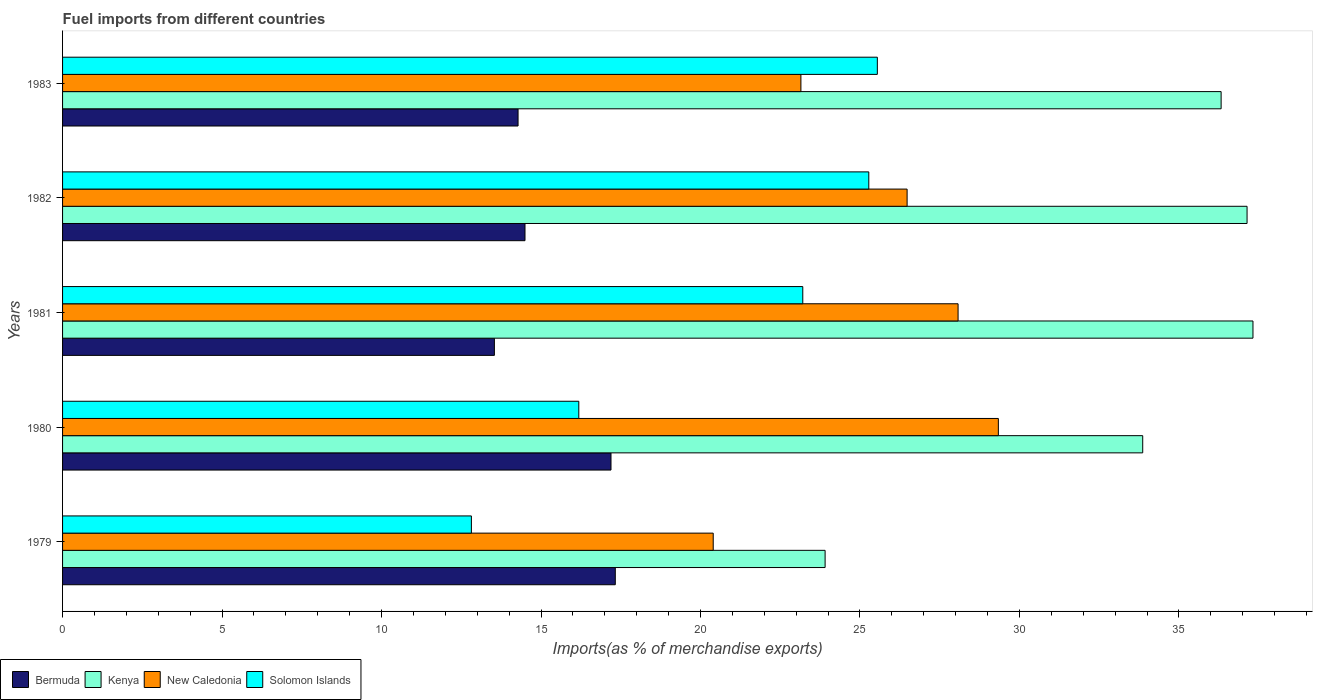Are the number of bars per tick equal to the number of legend labels?
Ensure brevity in your answer.  Yes. How many bars are there on the 2nd tick from the bottom?
Make the answer very short. 4. What is the label of the 3rd group of bars from the top?
Your answer should be very brief. 1981. What is the percentage of imports to different countries in Kenya in 1983?
Your answer should be compact. 36.32. Across all years, what is the maximum percentage of imports to different countries in Bermuda?
Ensure brevity in your answer.  17.33. Across all years, what is the minimum percentage of imports to different countries in Kenya?
Offer a very short reply. 23.91. In which year was the percentage of imports to different countries in Bermuda maximum?
Offer a very short reply. 1979. In which year was the percentage of imports to different countries in New Caledonia minimum?
Offer a very short reply. 1979. What is the total percentage of imports to different countries in New Caledonia in the graph?
Your answer should be very brief. 127.44. What is the difference between the percentage of imports to different countries in New Caledonia in 1980 and that in 1981?
Offer a terse response. 1.26. What is the difference between the percentage of imports to different countries in Bermuda in 1983 and the percentage of imports to different countries in Solomon Islands in 1982?
Your response must be concise. -11. What is the average percentage of imports to different countries in Kenya per year?
Offer a very short reply. 33.71. In the year 1980, what is the difference between the percentage of imports to different countries in New Caledonia and percentage of imports to different countries in Solomon Islands?
Keep it short and to the point. 13.15. In how many years, is the percentage of imports to different countries in Kenya greater than 22 %?
Offer a terse response. 5. What is the ratio of the percentage of imports to different countries in Bermuda in 1979 to that in 1983?
Your answer should be compact. 1.21. What is the difference between the highest and the second highest percentage of imports to different countries in Kenya?
Your answer should be very brief. 0.19. What is the difference between the highest and the lowest percentage of imports to different countries in New Caledonia?
Your answer should be compact. 8.94. In how many years, is the percentage of imports to different countries in Kenya greater than the average percentage of imports to different countries in Kenya taken over all years?
Your answer should be compact. 4. Is it the case that in every year, the sum of the percentage of imports to different countries in Bermuda and percentage of imports to different countries in Solomon Islands is greater than the sum of percentage of imports to different countries in Kenya and percentage of imports to different countries in New Caledonia?
Offer a very short reply. No. What does the 1st bar from the top in 1981 represents?
Your answer should be compact. Solomon Islands. What does the 2nd bar from the bottom in 1983 represents?
Keep it short and to the point. Kenya. Are all the bars in the graph horizontal?
Ensure brevity in your answer.  Yes. What is the difference between two consecutive major ticks on the X-axis?
Keep it short and to the point. 5. Are the values on the major ticks of X-axis written in scientific E-notation?
Your answer should be compact. No. What is the title of the graph?
Your response must be concise. Fuel imports from different countries. What is the label or title of the X-axis?
Provide a succinct answer. Imports(as % of merchandise exports). What is the label or title of the Y-axis?
Ensure brevity in your answer.  Years. What is the Imports(as % of merchandise exports) in Bermuda in 1979?
Your response must be concise. 17.33. What is the Imports(as % of merchandise exports) in Kenya in 1979?
Your answer should be compact. 23.91. What is the Imports(as % of merchandise exports) of New Caledonia in 1979?
Ensure brevity in your answer.  20.4. What is the Imports(as % of merchandise exports) of Solomon Islands in 1979?
Your answer should be compact. 12.82. What is the Imports(as % of merchandise exports) in Bermuda in 1980?
Give a very brief answer. 17.19. What is the Imports(as % of merchandise exports) of Kenya in 1980?
Keep it short and to the point. 33.86. What is the Imports(as % of merchandise exports) of New Caledonia in 1980?
Your response must be concise. 29.34. What is the Imports(as % of merchandise exports) in Solomon Islands in 1980?
Ensure brevity in your answer.  16.18. What is the Imports(as % of merchandise exports) in Bermuda in 1981?
Provide a short and direct response. 13.54. What is the Imports(as % of merchandise exports) in Kenya in 1981?
Give a very brief answer. 37.32. What is the Imports(as % of merchandise exports) of New Caledonia in 1981?
Provide a succinct answer. 28.08. What is the Imports(as % of merchandise exports) in Solomon Islands in 1981?
Your answer should be compact. 23.21. What is the Imports(as % of merchandise exports) of Bermuda in 1982?
Give a very brief answer. 14.5. What is the Imports(as % of merchandise exports) in Kenya in 1982?
Provide a succinct answer. 37.14. What is the Imports(as % of merchandise exports) in New Caledonia in 1982?
Provide a succinct answer. 26.48. What is the Imports(as % of merchandise exports) in Solomon Islands in 1982?
Offer a very short reply. 25.28. What is the Imports(as % of merchandise exports) in Bermuda in 1983?
Offer a terse response. 14.28. What is the Imports(as % of merchandise exports) of Kenya in 1983?
Your answer should be very brief. 36.32. What is the Imports(as % of merchandise exports) in New Caledonia in 1983?
Offer a very short reply. 23.15. What is the Imports(as % of merchandise exports) in Solomon Islands in 1983?
Your answer should be compact. 25.54. Across all years, what is the maximum Imports(as % of merchandise exports) in Bermuda?
Offer a very short reply. 17.33. Across all years, what is the maximum Imports(as % of merchandise exports) in Kenya?
Your response must be concise. 37.32. Across all years, what is the maximum Imports(as % of merchandise exports) in New Caledonia?
Offer a very short reply. 29.34. Across all years, what is the maximum Imports(as % of merchandise exports) of Solomon Islands?
Provide a succinct answer. 25.54. Across all years, what is the minimum Imports(as % of merchandise exports) of Bermuda?
Provide a short and direct response. 13.54. Across all years, what is the minimum Imports(as % of merchandise exports) of Kenya?
Offer a very short reply. 23.91. Across all years, what is the minimum Imports(as % of merchandise exports) of New Caledonia?
Your response must be concise. 20.4. Across all years, what is the minimum Imports(as % of merchandise exports) in Solomon Islands?
Provide a short and direct response. 12.82. What is the total Imports(as % of merchandise exports) of Bermuda in the graph?
Ensure brevity in your answer.  76.84. What is the total Imports(as % of merchandise exports) in Kenya in the graph?
Your response must be concise. 168.55. What is the total Imports(as % of merchandise exports) in New Caledonia in the graph?
Ensure brevity in your answer.  127.44. What is the total Imports(as % of merchandise exports) of Solomon Islands in the graph?
Offer a terse response. 103.03. What is the difference between the Imports(as % of merchandise exports) in Bermuda in 1979 and that in 1980?
Offer a terse response. 0.14. What is the difference between the Imports(as % of merchandise exports) of Kenya in 1979 and that in 1980?
Provide a short and direct response. -9.96. What is the difference between the Imports(as % of merchandise exports) in New Caledonia in 1979 and that in 1980?
Keep it short and to the point. -8.94. What is the difference between the Imports(as % of merchandise exports) in Solomon Islands in 1979 and that in 1980?
Provide a succinct answer. -3.37. What is the difference between the Imports(as % of merchandise exports) in Bermuda in 1979 and that in 1981?
Your answer should be very brief. 3.79. What is the difference between the Imports(as % of merchandise exports) in Kenya in 1979 and that in 1981?
Provide a short and direct response. -13.41. What is the difference between the Imports(as % of merchandise exports) in New Caledonia in 1979 and that in 1981?
Your response must be concise. -7.68. What is the difference between the Imports(as % of merchandise exports) of Solomon Islands in 1979 and that in 1981?
Offer a very short reply. -10.39. What is the difference between the Imports(as % of merchandise exports) of Bermuda in 1979 and that in 1982?
Your response must be concise. 2.83. What is the difference between the Imports(as % of merchandise exports) of Kenya in 1979 and that in 1982?
Your answer should be compact. -13.23. What is the difference between the Imports(as % of merchandise exports) in New Caledonia in 1979 and that in 1982?
Provide a succinct answer. -6.08. What is the difference between the Imports(as % of merchandise exports) in Solomon Islands in 1979 and that in 1982?
Your answer should be very brief. -12.46. What is the difference between the Imports(as % of merchandise exports) of Bermuda in 1979 and that in 1983?
Offer a very short reply. 3.05. What is the difference between the Imports(as % of merchandise exports) of Kenya in 1979 and that in 1983?
Your answer should be very brief. -12.42. What is the difference between the Imports(as % of merchandise exports) in New Caledonia in 1979 and that in 1983?
Your answer should be very brief. -2.75. What is the difference between the Imports(as % of merchandise exports) of Solomon Islands in 1979 and that in 1983?
Keep it short and to the point. -12.73. What is the difference between the Imports(as % of merchandise exports) in Bermuda in 1980 and that in 1981?
Your answer should be compact. 3.66. What is the difference between the Imports(as % of merchandise exports) in Kenya in 1980 and that in 1981?
Offer a terse response. -3.46. What is the difference between the Imports(as % of merchandise exports) in New Caledonia in 1980 and that in 1981?
Your answer should be very brief. 1.26. What is the difference between the Imports(as % of merchandise exports) of Solomon Islands in 1980 and that in 1981?
Ensure brevity in your answer.  -7.02. What is the difference between the Imports(as % of merchandise exports) of Bermuda in 1980 and that in 1982?
Offer a terse response. 2.7. What is the difference between the Imports(as % of merchandise exports) of Kenya in 1980 and that in 1982?
Provide a succinct answer. -3.27. What is the difference between the Imports(as % of merchandise exports) of New Caledonia in 1980 and that in 1982?
Your response must be concise. 2.86. What is the difference between the Imports(as % of merchandise exports) of Solomon Islands in 1980 and that in 1982?
Offer a terse response. -9.09. What is the difference between the Imports(as % of merchandise exports) in Bermuda in 1980 and that in 1983?
Give a very brief answer. 2.91. What is the difference between the Imports(as % of merchandise exports) of Kenya in 1980 and that in 1983?
Keep it short and to the point. -2.46. What is the difference between the Imports(as % of merchandise exports) of New Caledonia in 1980 and that in 1983?
Your answer should be compact. 6.19. What is the difference between the Imports(as % of merchandise exports) in Solomon Islands in 1980 and that in 1983?
Give a very brief answer. -9.36. What is the difference between the Imports(as % of merchandise exports) in Bermuda in 1981 and that in 1982?
Your answer should be very brief. -0.96. What is the difference between the Imports(as % of merchandise exports) of Kenya in 1981 and that in 1982?
Provide a succinct answer. 0.19. What is the difference between the Imports(as % of merchandise exports) of New Caledonia in 1981 and that in 1982?
Your answer should be very brief. 1.6. What is the difference between the Imports(as % of merchandise exports) in Solomon Islands in 1981 and that in 1982?
Provide a short and direct response. -2.07. What is the difference between the Imports(as % of merchandise exports) of Bermuda in 1981 and that in 1983?
Ensure brevity in your answer.  -0.74. What is the difference between the Imports(as % of merchandise exports) of Kenya in 1981 and that in 1983?
Provide a succinct answer. 1. What is the difference between the Imports(as % of merchandise exports) in New Caledonia in 1981 and that in 1983?
Provide a succinct answer. 4.93. What is the difference between the Imports(as % of merchandise exports) in Solomon Islands in 1981 and that in 1983?
Your response must be concise. -2.34. What is the difference between the Imports(as % of merchandise exports) of Bermuda in 1982 and that in 1983?
Make the answer very short. 0.22. What is the difference between the Imports(as % of merchandise exports) in Kenya in 1982 and that in 1983?
Offer a very short reply. 0.81. What is the difference between the Imports(as % of merchandise exports) in New Caledonia in 1982 and that in 1983?
Provide a short and direct response. 3.33. What is the difference between the Imports(as % of merchandise exports) in Solomon Islands in 1982 and that in 1983?
Your response must be concise. -0.27. What is the difference between the Imports(as % of merchandise exports) of Bermuda in 1979 and the Imports(as % of merchandise exports) of Kenya in 1980?
Offer a very short reply. -16.54. What is the difference between the Imports(as % of merchandise exports) of Bermuda in 1979 and the Imports(as % of merchandise exports) of New Caledonia in 1980?
Keep it short and to the point. -12.01. What is the difference between the Imports(as % of merchandise exports) of Bermuda in 1979 and the Imports(as % of merchandise exports) of Solomon Islands in 1980?
Keep it short and to the point. 1.14. What is the difference between the Imports(as % of merchandise exports) of Kenya in 1979 and the Imports(as % of merchandise exports) of New Caledonia in 1980?
Offer a very short reply. -5.43. What is the difference between the Imports(as % of merchandise exports) in Kenya in 1979 and the Imports(as % of merchandise exports) in Solomon Islands in 1980?
Provide a short and direct response. 7.72. What is the difference between the Imports(as % of merchandise exports) in New Caledonia in 1979 and the Imports(as % of merchandise exports) in Solomon Islands in 1980?
Ensure brevity in your answer.  4.21. What is the difference between the Imports(as % of merchandise exports) of Bermuda in 1979 and the Imports(as % of merchandise exports) of Kenya in 1981?
Offer a very short reply. -19.99. What is the difference between the Imports(as % of merchandise exports) in Bermuda in 1979 and the Imports(as % of merchandise exports) in New Caledonia in 1981?
Provide a short and direct response. -10.75. What is the difference between the Imports(as % of merchandise exports) of Bermuda in 1979 and the Imports(as % of merchandise exports) of Solomon Islands in 1981?
Provide a short and direct response. -5.88. What is the difference between the Imports(as % of merchandise exports) of Kenya in 1979 and the Imports(as % of merchandise exports) of New Caledonia in 1981?
Offer a terse response. -4.17. What is the difference between the Imports(as % of merchandise exports) in Kenya in 1979 and the Imports(as % of merchandise exports) in Solomon Islands in 1981?
Ensure brevity in your answer.  0.7. What is the difference between the Imports(as % of merchandise exports) in New Caledonia in 1979 and the Imports(as % of merchandise exports) in Solomon Islands in 1981?
Make the answer very short. -2.81. What is the difference between the Imports(as % of merchandise exports) of Bermuda in 1979 and the Imports(as % of merchandise exports) of Kenya in 1982?
Offer a very short reply. -19.81. What is the difference between the Imports(as % of merchandise exports) in Bermuda in 1979 and the Imports(as % of merchandise exports) in New Caledonia in 1982?
Keep it short and to the point. -9.15. What is the difference between the Imports(as % of merchandise exports) of Bermuda in 1979 and the Imports(as % of merchandise exports) of Solomon Islands in 1982?
Offer a very short reply. -7.95. What is the difference between the Imports(as % of merchandise exports) of Kenya in 1979 and the Imports(as % of merchandise exports) of New Caledonia in 1982?
Provide a short and direct response. -2.57. What is the difference between the Imports(as % of merchandise exports) of Kenya in 1979 and the Imports(as % of merchandise exports) of Solomon Islands in 1982?
Offer a terse response. -1.37. What is the difference between the Imports(as % of merchandise exports) of New Caledonia in 1979 and the Imports(as % of merchandise exports) of Solomon Islands in 1982?
Keep it short and to the point. -4.88. What is the difference between the Imports(as % of merchandise exports) in Bermuda in 1979 and the Imports(as % of merchandise exports) in Kenya in 1983?
Give a very brief answer. -18.99. What is the difference between the Imports(as % of merchandise exports) of Bermuda in 1979 and the Imports(as % of merchandise exports) of New Caledonia in 1983?
Your answer should be very brief. -5.82. What is the difference between the Imports(as % of merchandise exports) in Bermuda in 1979 and the Imports(as % of merchandise exports) in Solomon Islands in 1983?
Provide a short and direct response. -8.22. What is the difference between the Imports(as % of merchandise exports) in Kenya in 1979 and the Imports(as % of merchandise exports) in New Caledonia in 1983?
Give a very brief answer. 0.76. What is the difference between the Imports(as % of merchandise exports) of Kenya in 1979 and the Imports(as % of merchandise exports) of Solomon Islands in 1983?
Give a very brief answer. -1.64. What is the difference between the Imports(as % of merchandise exports) in New Caledonia in 1979 and the Imports(as % of merchandise exports) in Solomon Islands in 1983?
Keep it short and to the point. -5.15. What is the difference between the Imports(as % of merchandise exports) of Bermuda in 1980 and the Imports(as % of merchandise exports) of Kenya in 1981?
Offer a very short reply. -20.13. What is the difference between the Imports(as % of merchandise exports) in Bermuda in 1980 and the Imports(as % of merchandise exports) in New Caledonia in 1981?
Your answer should be very brief. -10.88. What is the difference between the Imports(as % of merchandise exports) of Bermuda in 1980 and the Imports(as % of merchandise exports) of Solomon Islands in 1981?
Your answer should be very brief. -6.01. What is the difference between the Imports(as % of merchandise exports) of Kenya in 1980 and the Imports(as % of merchandise exports) of New Caledonia in 1981?
Keep it short and to the point. 5.79. What is the difference between the Imports(as % of merchandise exports) of Kenya in 1980 and the Imports(as % of merchandise exports) of Solomon Islands in 1981?
Make the answer very short. 10.66. What is the difference between the Imports(as % of merchandise exports) in New Caledonia in 1980 and the Imports(as % of merchandise exports) in Solomon Islands in 1981?
Make the answer very short. 6.13. What is the difference between the Imports(as % of merchandise exports) in Bermuda in 1980 and the Imports(as % of merchandise exports) in Kenya in 1982?
Provide a succinct answer. -19.94. What is the difference between the Imports(as % of merchandise exports) of Bermuda in 1980 and the Imports(as % of merchandise exports) of New Caledonia in 1982?
Offer a very short reply. -9.28. What is the difference between the Imports(as % of merchandise exports) of Bermuda in 1980 and the Imports(as % of merchandise exports) of Solomon Islands in 1982?
Offer a very short reply. -8.08. What is the difference between the Imports(as % of merchandise exports) of Kenya in 1980 and the Imports(as % of merchandise exports) of New Caledonia in 1982?
Give a very brief answer. 7.39. What is the difference between the Imports(as % of merchandise exports) of Kenya in 1980 and the Imports(as % of merchandise exports) of Solomon Islands in 1982?
Your answer should be very brief. 8.59. What is the difference between the Imports(as % of merchandise exports) of New Caledonia in 1980 and the Imports(as % of merchandise exports) of Solomon Islands in 1982?
Give a very brief answer. 4.06. What is the difference between the Imports(as % of merchandise exports) of Bermuda in 1980 and the Imports(as % of merchandise exports) of Kenya in 1983?
Give a very brief answer. -19.13. What is the difference between the Imports(as % of merchandise exports) in Bermuda in 1980 and the Imports(as % of merchandise exports) in New Caledonia in 1983?
Your answer should be compact. -5.95. What is the difference between the Imports(as % of merchandise exports) in Bermuda in 1980 and the Imports(as % of merchandise exports) in Solomon Islands in 1983?
Ensure brevity in your answer.  -8.35. What is the difference between the Imports(as % of merchandise exports) in Kenya in 1980 and the Imports(as % of merchandise exports) in New Caledonia in 1983?
Your answer should be compact. 10.72. What is the difference between the Imports(as % of merchandise exports) in Kenya in 1980 and the Imports(as % of merchandise exports) in Solomon Islands in 1983?
Your answer should be compact. 8.32. What is the difference between the Imports(as % of merchandise exports) in New Caledonia in 1980 and the Imports(as % of merchandise exports) in Solomon Islands in 1983?
Make the answer very short. 3.79. What is the difference between the Imports(as % of merchandise exports) in Bermuda in 1981 and the Imports(as % of merchandise exports) in Kenya in 1982?
Your answer should be very brief. -23.6. What is the difference between the Imports(as % of merchandise exports) in Bermuda in 1981 and the Imports(as % of merchandise exports) in New Caledonia in 1982?
Provide a short and direct response. -12.94. What is the difference between the Imports(as % of merchandise exports) in Bermuda in 1981 and the Imports(as % of merchandise exports) in Solomon Islands in 1982?
Ensure brevity in your answer.  -11.74. What is the difference between the Imports(as % of merchandise exports) of Kenya in 1981 and the Imports(as % of merchandise exports) of New Caledonia in 1982?
Ensure brevity in your answer.  10.84. What is the difference between the Imports(as % of merchandise exports) of Kenya in 1981 and the Imports(as % of merchandise exports) of Solomon Islands in 1982?
Provide a short and direct response. 12.04. What is the difference between the Imports(as % of merchandise exports) in New Caledonia in 1981 and the Imports(as % of merchandise exports) in Solomon Islands in 1982?
Your response must be concise. 2.8. What is the difference between the Imports(as % of merchandise exports) in Bermuda in 1981 and the Imports(as % of merchandise exports) in Kenya in 1983?
Provide a short and direct response. -22.78. What is the difference between the Imports(as % of merchandise exports) in Bermuda in 1981 and the Imports(as % of merchandise exports) in New Caledonia in 1983?
Give a very brief answer. -9.61. What is the difference between the Imports(as % of merchandise exports) of Bermuda in 1981 and the Imports(as % of merchandise exports) of Solomon Islands in 1983?
Give a very brief answer. -12.01. What is the difference between the Imports(as % of merchandise exports) in Kenya in 1981 and the Imports(as % of merchandise exports) in New Caledonia in 1983?
Provide a succinct answer. 14.17. What is the difference between the Imports(as % of merchandise exports) of Kenya in 1981 and the Imports(as % of merchandise exports) of Solomon Islands in 1983?
Provide a succinct answer. 11.78. What is the difference between the Imports(as % of merchandise exports) of New Caledonia in 1981 and the Imports(as % of merchandise exports) of Solomon Islands in 1983?
Provide a succinct answer. 2.53. What is the difference between the Imports(as % of merchandise exports) in Bermuda in 1982 and the Imports(as % of merchandise exports) in Kenya in 1983?
Provide a short and direct response. -21.82. What is the difference between the Imports(as % of merchandise exports) of Bermuda in 1982 and the Imports(as % of merchandise exports) of New Caledonia in 1983?
Offer a terse response. -8.65. What is the difference between the Imports(as % of merchandise exports) in Bermuda in 1982 and the Imports(as % of merchandise exports) in Solomon Islands in 1983?
Offer a very short reply. -11.05. What is the difference between the Imports(as % of merchandise exports) in Kenya in 1982 and the Imports(as % of merchandise exports) in New Caledonia in 1983?
Ensure brevity in your answer.  13.99. What is the difference between the Imports(as % of merchandise exports) in Kenya in 1982 and the Imports(as % of merchandise exports) in Solomon Islands in 1983?
Give a very brief answer. 11.59. What is the difference between the Imports(as % of merchandise exports) in New Caledonia in 1982 and the Imports(as % of merchandise exports) in Solomon Islands in 1983?
Provide a short and direct response. 0.93. What is the average Imports(as % of merchandise exports) of Bermuda per year?
Provide a succinct answer. 15.37. What is the average Imports(as % of merchandise exports) of Kenya per year?
Offer a very short reply. 33.71. What is the average Imports(as % of merchandise exports) in New Caledonia per year?
Offer a very short reply. 25.49. What is the average Imports(as % of merchandise exports) of Solomon Islands per year?
Your answer should be compact. 20.61. In the year 1979, what is the difference between the Imports(as % of merchandise exports) in Bermuda and Imports(as % of merchandise exports) in Kenya?
Ensure brevity in your answer.  -6.58. In the year 1979, what is the difference between the Imports(as % of merchandise exports) of Bermuda and Imports(as % of merchandise exports) of New Caledonia?
Give a very brief answer. -3.07. In the year 1979, what is the difference between the Imports(as % of merchandise exports) of Bermuda and Imports(as % of merchandise exports) of Solomon Islands?
Keep it short and to the point. 4.51. In the year 1979, what is the difference between the Imports(as % of merchandise exports) of Kenya and Imports(as % of merchandise exports) of New Caledonia?
Provide a succinct answer. 3.51. In the year 1979, what is the difference between the Imports(as % of merchandise exports) in Kenya and Imports(as % of merchandise exports) in Solomon Islands?
Your answer should be compact. 11.09. In the year 1979, what is the difference between the Imports(as % of merchandise exports) of New Caledonia and Imports(as % of merchandise exports) of Solomon Islands?
Your answer should be compact. 7.58. In the year 1980, what is the difference between the Imports(as % of merchandise exports) in Bermuda and Imports(as % of merchandise exports) in Kenya?
Offer a very short reply. -16.67. In the year 1980, what is the difference between the Imports(as % of merchandise exports) in Bermuda and Imports(as % of merchandise exports) in New Caledonia?
Provide a succinct answer. -12.14. In the year 1980, what is the difference between the Imports(as % of merchandise exports) of Bermuda and Imports(as % of merchandise exports) of Solomon Islands?
Your response must be concise. 1.01. In the year 1980, what is the difference between the Imports(as % of merchandise exports) in Kenya and Imports(as % of merchandise exports) in New Caledonia?
Provide a short and direct response. 4.53. In the year 1980, what is the difference between the Imports(as % of merchandise exports) in Kenya and Imports(as % of merchandise exports) in Solomon Islands?
Your response must be concise. 17.68. In the year 1980, what is the difference between the Imports(as % of merchandise exports) in New Caledonia and Imports(as % of merchandise exports) in Solomon Islands?
Offer a very short reply. 13.15. In the year 1981, what is the difference between the Imports(as % of merchandise exports) in Bermuda and Imports(as % of merchandise exports) in Kenya?
Ensure brevity in your answer.  -23.78. In the year 1981, what is the difference between the Imports(as % of merchandise exports) in Bermuda and Imports(as % of merchandise exports) in New Caledonia?
Keep it short and to the point. -14.54. In the year 1981, what is the difference between the Imports(as % of merchandise exports) in Bermuda and Imports(as % of merchandise exports) in Solomon Islands?
Your answer should be very brief. -9.67. In the year 1981, what is the difference between the Imports(as % of merchandise exports) of Kenya and Imports(as % of merchandise exports) of New Caledonia?
Keep it short and to the point. 9.25. In the year 1981, what is the difference between the Imports(as % of merchandise exports) in Kenya and Imports(as % of merchandise exports) in Solomon Islands?
Your answer should be very brief. 14.11. In the year 1981, what is the difference between the Imports(as % of merchandise exports) of New Caledonia and Imports(as % of merchandise exports) of Solomon Islands?
Ensure brevity in your answer.  4.87. In the year 1982, what is the difference between the Imports(as % of merchandise exports) of Bermuda and Imports(as % of merchandise exports) of Kenya?
Keep it short and to the point. -22.64. In the year 1982, what is the difference between the Imports(as % of merchandise exports) in Bermuda and Imports(as % of merchandise exports) in New Caledonia?
Ensure brevity in your answer.  -11.98. In the year 1982, what is the difference between the Imports(as % of merchandise exports) of Bermuda and Imports(as % of merchandise exports) of Solomon Islands?
Make the answer very short. -10.78. In the year 1982, what is the difference between the Imports(as % of merchandise exports) in Kenya and Imports(as % of merchandise exports) in New Caledonia?
Your answer should be very brief. 10.66. In the year 1982, what is the difference between the Imports(as % of merchandise exports) of Kenya and Imports(as % of merchandise exports) of Solomon Islands?
Keep it short and to the point. 11.86. In the year 1982, what is the difference between the Imports(as % of merchandise exports) in New Caledonia and Imports(as % of merchandise exports) in Solomon Islands?
Your response must be concise. 1.2. In the year 1983, what is the difference between the Imports(as % of merchandise exports) in Bermuda and Imports(as % of merchandise exports) in Kenya?
Offer a very short reply. -22.04. In the year 1983, what is the difference between the Imports(as % of merchandise exports) in Bermuda and Imports(as % of merchandise exports) in New Caledonia?
Keep it short and to the point. -8.87. In the year 1983, what is the difference between the Imports(as % of merchandise exports) of Bermuda and Imports(as % of merchandise exports) of Solomon Islands?
Provide a short and direct response. -11.26. In the year 1983, what is the difference between the Imports(as % of merchandise exports) in Kenya and Imports(as % of merchandise exports) in New Caledonia?
Keep it short and to the point. 13.17. In the year 1983, what is the difference between the Imports(as % of merchandise exports) in Kenya and Imports(as % of merchandise exports) in Solomon Islands?
Your answer should be very brief. 10.78. In the year 1983, what is the difference between the Imports(as % of merchandise exports) in New Caledonia and Imports(as % of merchandise exports) in Solomon Islands?
Give a very brief answer. -2.4. What is the ratio of the Imports(as % of merchandise exports) in Bermuda in 1979 to that in 1980?
Your answer should be compact. 1.01. What is the ratio of the Imports(as % of merchandise exports) of Kenya in 1979 to that in 1980?
Your answer should be very brief. 0.71. What is the ratio of the Imports(as % of merchandise exports) of New Caledonia in 1979 to that in 1980?
Provide a succinct answer. 0.7. What is the ratio of the Imports(as % of merchandise exports) of Solomon Islands in 1979 to that in 1980?
Make the answer very short. 0.79. What is the ratio of the Imports(as % of merchandise exports) of Bermuda in 1979 to that in 1981?
Offer a terse response. 1.28. What is the ratio of the Imports(as % of merchandise exports) in Kenya in 1979 to that in 1981?
Your response must be concise. 0.64. What is the ratio of the Imports(as % of merchandise exports) in New Caledonia in 1979 to that in 1981?
Provide a succinct answer. 0.73. What is the ratio of the Imports(as % of merchandise exports) of Solomon Islands in 1979 to that in 1981?
Ensure brevity in your answer.  0.55. What is the ratio of the Imports(as % of merchandise exports) in Bermuda in 1979 to that in 1982?
Give a very brief answer. 1.2. What is the ratio of the Imports(as % of merchandise exports) in Kenya in 1979 to that in 1982?
Ensure brevity in your answer.  0.64. What is the ratio of the Imports(as % of merchandise exports) in New Caledonia in 1979 to that in 1982?
Your answer should be compact. 0.77. What is the ratio of the Imports(as % of merchandise exports) of Solomon Islands in 1979 to that in 1982?
Your answer should be compact. 0.51. What is the ratio of the Imports(as % of merchandise exports) in Bermuda in 1979 to that in 1983?
Make the answer very short. 1.21. What is the ratio of the Imports(as % of merchandise exports) of Kenya in 1979 to that in 1983?
Your answer should be very brief. 0.66. What is the ratio of the Imports(as % of merchandise exports) of New Caledonia in 1979 to that in 1983?
Provide a short and direct response. 0.88. What is the ratio of the Imports(as % of merchandise exports) in Solomon Islands in 1979 to that in 1983?
Your response must be concise. 0.5. What is the ratio of the Imports(as % of merchandise exports) in Bermuda in 1980 to that in 1981?
Offer a very short reply. 1.27. What is the ratio of the Imports(as % of merchandise exports) in Kenya in 1980 to that in 1981?
Your response must be concise. 0.91. What is the ratio of the Imports(as % of merchandise exports) of New Caledonia in 1980 to that in 1981?
Provide a short and direct response. 1.04. What is the ratio of the Imports(as % of merchandise exports) in Solomon Islands in 1980 to that in 1981?
Your response must be concise. 0.7. What is the ratio of the Imports(as % of merchandise exports) in Bermuda in 1980 to that in 1982?
Make the answer very short. 1.19. What is the ratio of the Imports(as % of merchandise exports) in Kenya in 1980 to that in 1982?
Your answer should be very brief. 0.91. What is the ratio of the Imports(as % of merchandise exports) in New Caledonia in 1980 to that in 1982?
Your answer should be very brief. 1.11. What is the ratio of the Imports(as % of merchandise exports) of Solomon Islands in 1980 to that in 1982?
Give a very brief answer. 0.64. What is the ratio of the Imports(as % of merchandise exports) of Bermuda in 1980 to that in 1983?
Keep it short and to the point. 1.2. What is the ratio of the Imports(as % of merchandise exports) of Kenya in 1980 to that in 1983?
Offer a very short reply. 0.93. What is the ratio of the Imports(as % of merchandise exports) in New Caledonia in 1980 to that in 1983?
Ensure brevity in your answer.  1.27. What is the ratio of the Imports(as % of merchandise exports) of Solomon Islands in 1980 to that in 1983?
Keep it short and to the point. 0.63. What is the ratio of the Imports(as % of merchandise exports) in Bermuda in 1981 to that in 1982?
Your response must be concise. 0.93. What is the ratio of the Imports(as % of merchandise exports) of Kenya in 1981 to that in 1982?
Provide a succinct answer. 1. What is the ratio of the Imports(as % of merchandise exports) of New Caledonia in 1981 to that in 1982?
Offer a terse response. 1.06. What is the ratio of the Imports(as % of merchandise exports) in Solomon Islands in 1981 to that in 1982?
Your response must be concise. 0.92. What is the ratio of the Imports(as % of merchandise exports) in Bermuda in 1981 to that in 1983?
Provide a short and direct response. 0.95. What is the ratio of the Imports(as % of merchandise exports) of Kenya in 1981 to that in 1983?
Ensure brevity in your answer.  1.03. What is the ratio of the Imports(as % of merchandise exports) in New Caledonia in 1981 to that in 1983?
Your answer should be compact. 1.21. What is the ratio of the Imports(as % of merchandise exports) of Solomon Islands in 1981 to that in 1983?
Keep it short and to the point. 0.91. What is the ratio of the Imports(as % of merchandise exports) in Bermuda in 1982 to that in 1983?
Offer a terse response. 1.02. What is the ratio of the Imports(as % of merchandise exports) in Kenya in 1982 to that in 1983?
Offer a very short reply. 1.02. What is the ratio of the Imports(as % of merchandise exports) of New Caledonia in 1982 to that in 1983?
Offer a terse response. 1.14. What is the difference between the highest and the second highest Imports(as % of merchandise exports) in Bermuda?
Offer a very short reply. 0.14. What is the difference between the highest and the second highest Imports(as % of merchandise exports) of Kenya?
Give a very brief answer. 0.19. What is the difference between the highest and the second highest Imports(as % of merchandise exports) in New Caledonia?
Your answer should be very brief. 1.26. What is the difference between the highest and the second highest Imports(as % of merchandise exports) of Solomon Islands?
Ensure brevity in your answer.  0.27. What is the difference between the highest and the lowest Imports(as % of merchandise exports) in Bermuda?
Keep it short and to the point. 3.79. What is the difference between the highest and the lowest Imports(as % of merchandise exports) of Kenya?
Your response must be concise. 13.41. What is the difference between the highest and the lowest Imports(as % of merchandise exports) in New Caledonia?
Ensure brevity in your answer.  8.94. What is the difference between the highest and the lowest Imports(as % of merchandise exports) of Solomon Islands?
Keep it short and to the point. 12.73. 